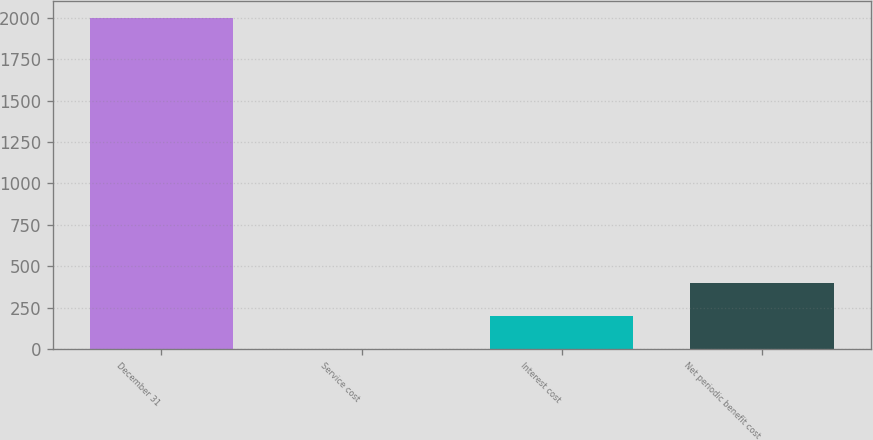Convert chart. <chart><loc_0><loc_0><loc_500><loc_500><bar_chart><fcel>December 31<fcel>Service cost<fcel>Interest cost<fcel>Net periodic benefit cost<nl><fcel>2002<fcel>1.1<fcel>201.19<fcel>401.28<nl></chart> 